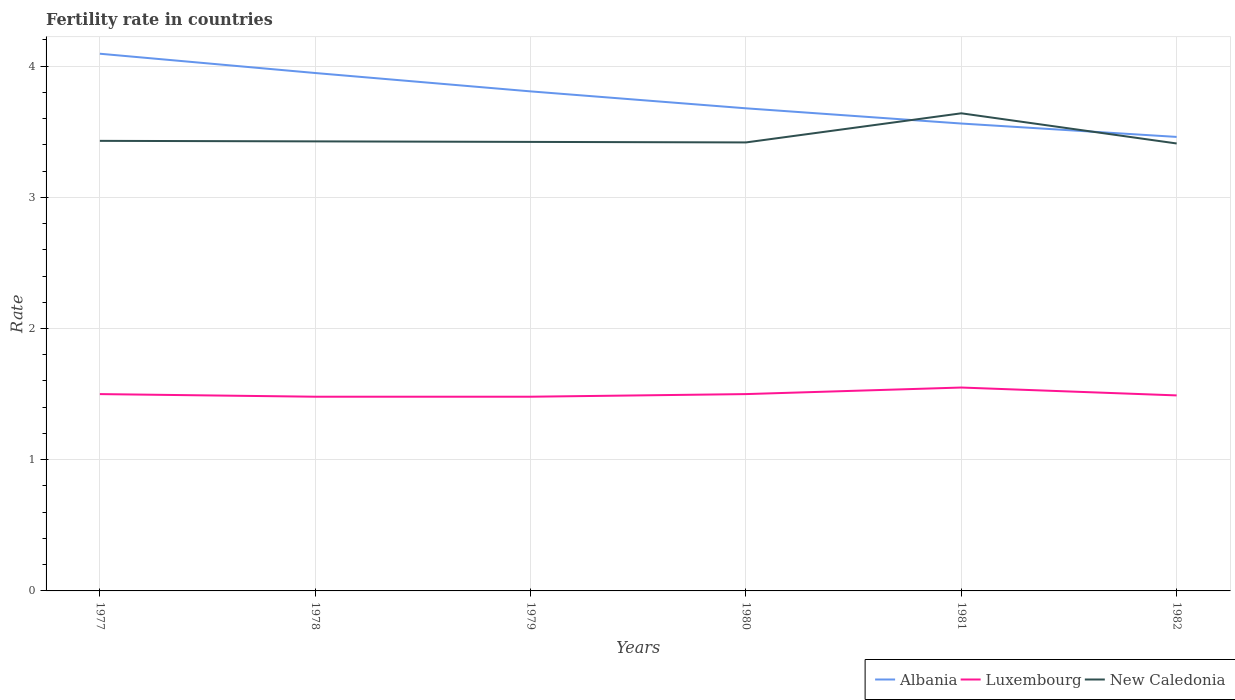Is the number of lines equal to the number of legend labels?
Keep it short and to the point. Yes. Across all years, what is the maximum fertility rate in New Caledonia?
Your answer should be very brief. 3.41. In which year was the fertility rate in New Caledonia maximum?
Your answer should be compact. 1982. What is the total fertility rate in Luxembourg in the graph?
Keep it short and to the point. 0.01. What is the difference between the highest and the second highest fertility rate in Albania?
Give a very brief answer. 0.63. Is the fertility rate in New Caledonia strictly greater than the fertility rate in Albania over the years?
Make the answer very short. No. What is the difference between two consecutive major ticks on the Y-axis?
Offer a terse response. 1. Are the values on the major ticks of Y-axis written in scientific E-notation?
Keep it short and to the point. No. Does the graph contain any zero values?
Provide a succinct answer. No. Does the graph contain grids?
Provide a short and direct response. Yes. How many legend labels are there?
Your answer should be compact. 3. What is the title of the graph?
Keep it short and to the point. Fertility rate in countries. What is the label or title of the X-axis?
Ensure brevity in your answer.  Years. What is the label or title of the Y-axis?
Keep it short and to the point. Rate. What is the Rate in Albania in 1977?
Provide a short and direct response. 4.09. What is the Rate in Luxembourg in 1977?
Offer a very short reply. 1.5. What is the Rate of New Caledonia in 1977?
Your answer should be very brief. 3.43. What is the Rate of Albania in 1978?
Offer a very short reply. 3.95. What is the Rate of Luxembourg in 1978?
Provide a short and direct response. 1.48. What is the Rate of New Caledonia in 1978?
Provide a short and direct response. 3.43. What is the Rate in Albania in 1979?
Ensure brevity in your answer.  3.81. What is the Rate of Luxembourg in 1979?
Your response must be concise. 1.48. What is the Rate in New Caledonia in 1979?
Your answer should be very brief. 3.42. What is the Rate in Albania in 1980?
Provide a short and direct response. 3.68. What is the Rate in Luxembourg in 1980?
Your answer should be very brief. 1.5. What is the Rate of New Caledonia in 1980?
Provide a short and direct response. 3.42. What is the Rate of Albania in 1981?
Offer a very short reply. 3.56. What is the Rate in Luxembourg in 1981?
Ensure brevity in your answer.  1.55. What is the Rate of New Caledonia in 1981?
Keep it short and to the point. 3.64. What is the Rate of Albania in 1982?
Offer a very short reply. 3.46. What is the Rate of Luxembourg in 1982?
Give a very brief answer. 1.49. What is the Rate of New Caledonia in 1982?
Give a very brief answer. 3.41. Across all years, what is the maximum Rate of Albania?
Provide a succinct answer. 4.09. Across all years, what is the maximum Rate of Luxembourg?
Make the answer very short. 1.55. Across all years, what is the maximum Rate in New Caledonia?
Offer a terse response. 3.64. Across all years, what is the minimum Rate in Albania?
Make the answer very short. 3.46. Across all years, what is the minimum Rate of Luxembourg?
Offer a terse response. 1.48. Across all years, what is the minimum Rate in New Caledonia?
Ensure brevity in your answer.  3.41. What is the total Rate in Albania in the graph?
Offer a very short reply. 22.55. What is the total Rate of Luxembourg in the graph?
Provide a short and direct response. 9. What is the total Rate of New Caledonia in the graph?
Offer a terse response. 20.75. What is the difference between the Rate of Albania in 1977 and that in 1978?
Keep it short and to the point. 0.15. What is the difference between the Rate of Luxembourg in 1977 and that in 1978?
Make the answer very short. 0.02. What is the difference between the Rate of New Caledonia in 1977 and that in 1978?
Your answer should be compact. 0. What is the difference between the Rate in Albania in 1977 and that in 1979?
Ensure brevity in your answer.  0.29. What is the difference between the Rate in New Caledonia in 1977 and that in 1979?
Give a very brief answer. 0.01. What is the difference between the Rate in Albania in 1977 and that in 1980?
Your response must be concise. 0.42. What is the difference between the Rate in New Caledonia in 1977 and that in 1980?
Your answer should be compact. 0.01. What is the difference between the Rate of Albania in 1977 and that in 1981?
Offer a very short reply. 0.53. What is the difference between the Rate of New Caledonia in 1977 and that in 1981?
Your answer should be compact. -0.21. What is the difference between the Rate in Albania in 1977 and that in 1982?
Offer a terse response. 0.63. What is the difference between the Rate of Luxembourg in 1977 and that in 1982?
Offer a very short reply. 0.01. What is the difference between the Rate of Albania in 1978 and that in 1979?
Your response must be concise. 0.14. What is the difference between the Rate in New Caledonia in 1978 and that in 1979?
Offer a very short reply. 0. What is the difference between the Rate of Albania in 1978 and that in 1980?
Provide a short and direct response. 0.27. What is the difference between the Rate in Luxembourg in 1978 and that in 1980?
Your answer should be very brief. -0.02. What is the difference between the Rate in New Caledonia in 1978 and that in 1980?
Provide a succinct answer. 0.01. What is the difference between the Rate in Albania in 1978 and that in 1981?
Offer a very short reply. 0.39. What is the difference between the Rate of Luxembourg in 1978 and that in 1981?
Keep it short and to the point. -0.07. What is the difference between the Rate in New Caledonia in 1978 and that in 1981?
Offer a very short reply. -0.21. What is the difference between the Rate in Albania in 1978 and that in 1982?
Make the answer very short. 0.49. What is the difference between the Rate in Luxembourg in 1978 and that in 1982?
Ensure brevity in your answer.  -0.01. What is the difference between the Rate of New Caledonia in 1978 and that in 1982?
Offer a terse response. 0.02. What is the difference between the Rate in Albania in 1979 and that in 1980?
Your response must be concise. 0.13. What is the difference between the Rate in Luxembourg in 1979 and that in 1980?
Keep it short and to the point. -0.02. What is the difference between the Rate of New Caledonia in 1979 and that in 1980?
Your response must be concise. 0. What is the difference between the Rate of Albania in 1979 and that in 1981?
Your answer should be compact. 0.24. What is the difference between the Rate of Luxembourg in 1979 and that in 1981?
Keep it short and to the point. -0.07. What is the difference between the Rate of New Caledonia in 1979 and that in 1981?
Your answer should be very brief. -0.22. What is the difference between the Rate of Albania in 1979 and that in 1982?
Your answer should be very brief. 0.35. What is the difference between the Rate in Luxembourg in 1979 and that in 1982?
Provide a short and direct response. -0.01. What is the difference between the Rate of New Caledonia in 1979 and that in 1982?
Make the answer very short. 0.01. What is the difference between the Rate of Albania in 1980 and that in 1981?
Offer a terse response. 0.12. What is the difference between the Rate in Luxembourg in 1980 and that in 1981?
Your answer should be compact. -0.05. What is the difference between the Rate of New Caledonia in 1980 and that in 1981?
Give a very brief answer. -0.22. What is the difference between the Rate of Albania in 1980 and that in 1982?
Give a very brief answer. 0.22. What is the difference between the Rate of New Caledonia in 1980 and that in 1982?
Offer a very short reply. 0.01. What is the difference between the Rate in Albania in 1981 and that in 1982?
Offer a very short reply. 0.1. What is the difference between the Rate of New Caledonia in 1981 and that in 1982?
Provide a succinct answer. 0.23. What is the difference between the Rate of Albania in 1977 and the Rate of Luxembourg in 1978?
Your response must be concise. 2.61. What is the difference between the Rate in Albania in 1977 and the Rate in New Caledonia in 1978?
Provide a short and direct response. 0.67. What is the difference between the Rate in Luxembourg in 1977 and the Rate in New Caledonia in 1978?
Provide a short and direct response. -1.93. What is the difference between the Rate in Albania in 1977 and the Rate in Luxembourg in 1979?
Make the answer very short. 2.61. What is the difference between the Rate of Albania in 1977 and the Rate of New Caledonia in 1979?
Ensure brevity in your answer.  0.67. What is the difference between the Rate of Luxembourg in 1977 and the Rate of New Caledonia in 1979?
Provide a succinct answer. -1.92. What is the difference between the Rate of Albania in 1977 and the Rate of Luxembourg in 1980?
Your answer should be compact. 2.59. What is the difference between the Rate in Albania in 1977 and the Rate in New Caledonia in 1980?
Offer a terse response. 0.68. What is the difference between the Rate in Luxembourg in 1977 and the Rate in New Caledonia in 1980?
Keep it short and to the point. -1.92. What is the difference between the Rate in Albania in 1977 and the Rate in Luxembourg in 1981?
Your answer should be compact. 2.54. What is the difference between the Rate in Albania in 1977 and the Rate in New Caledonia in 1981?
Your response must be concise. 0.45. What is the difference between the Rate in Luxembourg in 1977 and the Rate in New Caledonia in 1981?
Provide a short and direct response. -2.14. What is the difference between the Rate in Albania in 1977 and the Rate in Luxembourg in 1982?
Ensure brevity in your answer.  2.6. What is the difference between the Rate of Albania in 1977 and the Rate of New Caledonia in 1982?
Your answer should be very brief. 0.68. What is the difference between the Rate in Luxembourg in 1977 and the Rate in New Caledonia in 1982?
Offer a terse response. -1.91. What is the difference between the Rate in Albania in 1978 and the Rate in Luxembourg in 1979?
Keep it short and to the point. 2.47. What is the difference between the Rate in Albania in 1978 and the Rate in New Caledonia in 1979?
Offer a terse response. 0.53. What is the difference between the Rate in Luxembourg in 1978 and the Rate in New Caledonia in 1979?
Provide a short and direct response. -1.94. What is the difference between the Rate of Albania in 1978 and the Rate of Luxembourg in 1980?
Keep it short and to the point. 2.45. What is the difference between the Rate in Albania in 1978 and the Rate in New Caledonia in 1980?
Provide a short and direct response. 0.53. What is the difference between the Rate of Luxembourg in 1978 and the Rate of New Caledonia in 1980?
Make the answer very short. -1.94. What is the difference between the Rate of Albania in 1978 and the Rate of Luxembourg in 1981?
Keep it short and to the point. 2.4. What is the difference between the Rate of Albania in 1978 and the Rate of New Caledonia in 1981?
Make the answer very short. 0.31. What is the difference between the Rate of Luxembourg in 1978 and the Rate of New Caledonia in 1981?
Keep it short and to the point. -2.16. What is the difference between the Rate in Albania in 1978 and the Rate in Luxembourg in 1982?
Ensure brevity in your answer.  2.46. What is the difference between the Rate in Albania in 1978 and the Rate in New Caledonia in 1982?
Give a very brief answer. 0.54. What is the difference between the Rate in Luxembourg in 1978 and the Rate in New Caledonia in 1982?
Keep it short and to the point. -1.93. What is the difference between the Rate in Albania in 1979 and the Rate in Luxembourg in 1980?
Keep it short and to the point. 2.31. What is the difference between the Rate in Albania in 1979 and the Rate in New Caledonia in 1980?
Your answer should be compact. 0.39. What is the difference between the Rate of Luxembourg in 1979 and the Rate of New Caledonia in 1980?
Give a very brief answer. -1.94. What is the difference between the Rate in Albania in 1979 and the Rate in Luxembourg in 1981?
Your answer should be very brief. 2.26. What is the difference between the Rate of Albania in 1979 and the Rate of New Caledonia in 1981?
Make the answer very short. 0.17. What is the difference between the Rate in Luxembourg in 1979 and the Rate in New Caledonia in 1981?
Offer a very short reply. -2.16. What is the difference between the Rate in Albania in 1979 and the Rate in Luxembourg in 1982?
Offer a very short reply. 2.32. What is the difference between the Rate in Albania in 1979 and the Rate in New Caledonia in 1982?
Make the answer very short. 0.4. What is the difference between the Rate of Luxembourg in 1979 and the Rate of New Caledonia in 1982?
Your answer should be compact. -1.93. What is the difference between the Rate of Albania in 1980 and the Rate of Luxembourg in 1981?
Give a very brief answer. 2.13. What is the difference between the Rate in Albania in 1980 and the Rate in New Caledonia in 1981?
Make the answer very short. 0.04. What is the difference between the Rate of Luxembourg in 1980 and the Rate of New Caledonia in 1981?
Make the answer very short. -2.14. What is the difference between the Rate of Albania in 1980 and the Rate of Luxembourg in 1982?
Offer a very short reply. 2.19. What is the difference between the Rate of Albania in 1980 and the Rate of New Caledonia in 1982?
Offer a very short reply. 0.27. What is the difference between the Rate of Luxembourg in 1980 and the Rate of New Caledonia in 1982?
Give a very brief answer. -1.91. What is the difference between the Rate of Albania in 1981 and the Rate of Luxembourg in 1982?
Offer a very short reply. 2.07. What is the difference between the Rate of Albania in 1981 and the Rate of New Caledonia in 1982?
Offer a very short reply. 0.15. What is the difference between the Rate of Luxembourg in 1981 and the Rate of New Caledonia in 1982?
Offer a terse response. -1.86. What is the average Rate of Albania per year?
Provide a succinct answer. 3.76. What is the average Rate of Luxembourg per year?
Make the answer very short. 1.5. What is the average Rate in New Caledonia per year?
Provide a succinct answer. 3.46. In the year 1977, what is the difference between the Rate of Albania and Rate of Luxembourg?
Your answer should be very brief. 2.59. In the year 1977, what is the difference between the Rate in Albania and Rate in New Caledonia?
Ensure brevity in your answer.  0.66. In the year 1977, what is the difference between the Rate of Luxembourg and Rate of New Caledonia?
Offer a terse response. -1.93. In the year 1978, what is the difference between the Rate in Albania and Rate in Luxembourg?
Your answer should be compact. 2.47. In the year 1978, what is the difference between the Rate in Albania and Rate in New Caledonia?
Your response must be concise. 0.52. In the year 1978, what is the difference between the Rate in Luxembourg and Rate in New Caledonia?
Offer a very short reply. -1.95. In the year 1979, what is the difference between the Rate in Albania and Rate in Luxembourg?
Offer a terse response. 2.33. In the year 1979, what is the difference between the Rate in Albania and Rate in New Caledonia?
Provide a succinct answer. 0.39. In the year 1979, what is the difference between the Rate of Luxembourg and Rate of New Caledonia?
Your answer should be compact. -1.94. In the year 1980, what is the difference between the Rate of Albania and Rate of Luxembourg?
Keep it short and to the point. 2.18. In the year 1980, what is the difference between the Rate of Albania and Rate of New Caledonia?
Provide a succinct answer. 0.26. In the year 1980, what is the difference between the Rate in Luxembourg and Rate in New Caledonia?
Give a very brief answer. -1.92. In the year 1981, what is the difference between the Rate of Albania and Rate of Luxembourg?
Your answer should be very brief. 2.01. In the year 1981, what is the difference between the Rate of Albania and Rate of New Caledonia?
Offer a very short reply. -0.08. In the year 1981, what is the difference between the Rate of Luxembourg and Rate of New Caledonia?
Your response must be concise. -2.09. In the year 1982, what is the difference between the Rate of Albania and Rate of Luxembourg?
Your answer should be very brief. 1.97. In the year 1982, what is the difference between the Rate in Luxembourg and Rate in New Caledonia?
Your answer should be very brief. -1.92. What is the ratio of the Rate in Albania in 1977 to that in 1978?
Provide a succinct answer. 1.04. What is the ratio of the Rate of Luxembourg in 1977 to that in 1978?
Your answer should be compact. 1.01. What is the ratio of the Rate of Albania in 1977 to that in 1979?
Provide a succinct answer. 1.08. What is the ratio of the Rate of Luxembourg in 1977 to that in 1979?
Give a very brief answer. 1.01. What is the ratio of the Rate of Albania in 1977 to that in 1980?
Offer a terse response. 1.11. What is the ratio of the Rate in New Caledonia in 1977 to that in 1980?
Make the answer very short. 1. What is the ratio of the Rate of Albania in 1977 to that in 1981?
Your answer should be compact. 1.15. What is the ratio of the Rate in New Caledonia in 1977 to that in 1981?
Your answer should be compact. 0.94. What is the ratio of the Rate in Albania in 1977 to that in 1982?
Provide a short and direct response. 1.18. What is the ratio of the Rate in New Caledonia in 1977 to that in 1982?
Offer a very short reply. 1.01. What is the ratio of the Rate of Albania in 1978 to that in 1979?
Ensure brevity in your answer.  1.04. What is the ratio of the Rate in Albania in 1978 to that in 1980?
Your answer should be very brief. 1.07. What is the ratio of the Rate in Luxembourg in 1978 to that in 1980?
Offer a terse response. 0.99. What is the ratio of the Rate in New Caledonia in 1978 to that in 1980?
Make the answer very short. 1. What is the ratio of the Rate of Albania in 1978 to that in 1981?
Offer a very short reply. 1.11. What is the ratio of the Rate of Luxembourg in 1978 to that in 1981?
Offer a very short reply. 0.95. What is the ratio of the Rate in Albania in 1978 to that in 1982?
Offer a very short reply. 1.14. What is the ratio of the Rate in Luxembourg in 1978 to that in 1982?
Your response must be concise. 0.99. What is the ratio of the Rate of New Caledonia in 1978 to that in 1982?
Give a very brief answer. 1. What is the ratio of the Rate of Albania in 1979 to that in 1980?
Provide a succinct answer. 1.04. What is the ratio of the Rate of Luxembourg in 1979 to that in 1980?
Provide a short and direct response. 0.99. What is the ratio of the Rate of Albania in 1979 to that in 1981?
Keep it short and to the point. 1.07. What is the ratio of the Rate in Luxembourg in 1979 to that in 1981?
Your answer should be compact. 0.95. What is the ratio of the Rate in New Caledonia in 1979 to that in 1981?
Give a very brief answer. 0.94. What is the ratio of the Rate in Albania in 1979 to that in 1982?
Give a very brief answer. 1.1. What is the ratio of the Rate in Luxembourg in 1979 to that in 1982?
Your answer should be very brief. 0.99. What is the ratio of the Rate of New Caledonia in 1979 to that in 1982?
Keep it short and to the point. 1. What is the ratio of the Rate of Albania in 1980 to that in 1981?
Your response must be concise. 1.03. What is the ratio of the Rate in Luxembourg in 1980 to that in 1981?
Your response must be concise. 0.97. What is the ratio of the Rate of New Caledonia in 1980 to that in 1981?
Give a very brief answer. 0.94. What is the ratio of the Rate of Albania in 1980 to that in 1982?
Offer a terse response. 1.06. What is the ratio of the Rate in Albania in 1981 to that in 1982?
Your response must be concise. 1.03. What is the ratio of the Rate of Luxembourg in 1981 to that in 1982?
Your response must be concise. 1.04. What is the ratio of the Rate in New Caledonia in 1981 to that in 1982?
Your answer should be very brief. 1.07. What is the difference between the highest and the second highest Rate of Albania?
Provide a short and direct response. 0.15. What is the difference between the highest and the second highest Rate in Luxembourg?
Keep it short and to the point. 0.05. What is the difference between the highest and the second highest Rate of New Caledonia?
Keep it short and to the point. 0.21. What is the difference between the highest and the lowest Rate of Albania?
Give a very brief answer. 0.63. What is the difference between the highest and the lowest Rate of Luxembourg?
Your answer should be compact. 0.07. What is the difference between the highest and the lowest Rate in New Caledonia?
Ensure brevity in your answer.  0.23. 